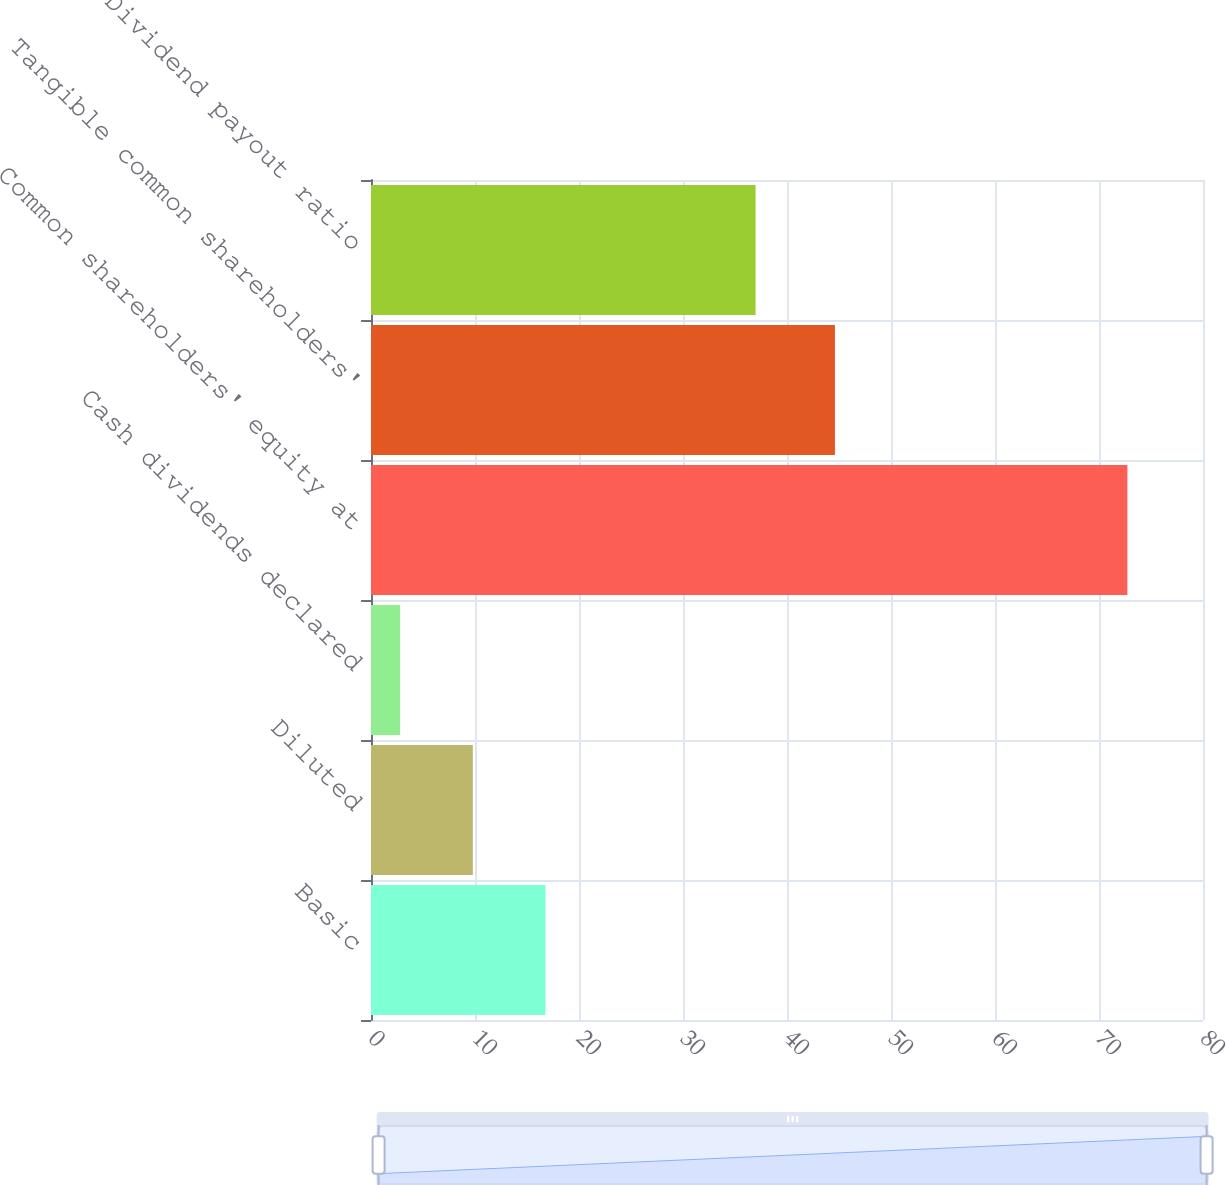<chart> <loc_0><loc_0><loc_500><loc_500><bar_chart><fcel>Basic<fcel>Diluted<fcel>Cash dividends declared<fcel>Common shareholders' equity at<fcel>Tangible common shareholders'<fcel>Dividend payout ratio<nl><fcel>16.78<fcel>9.79<fcel>2.8<fcel>72.73<fcel>44.61<fcel>36.98<nl></chart> 